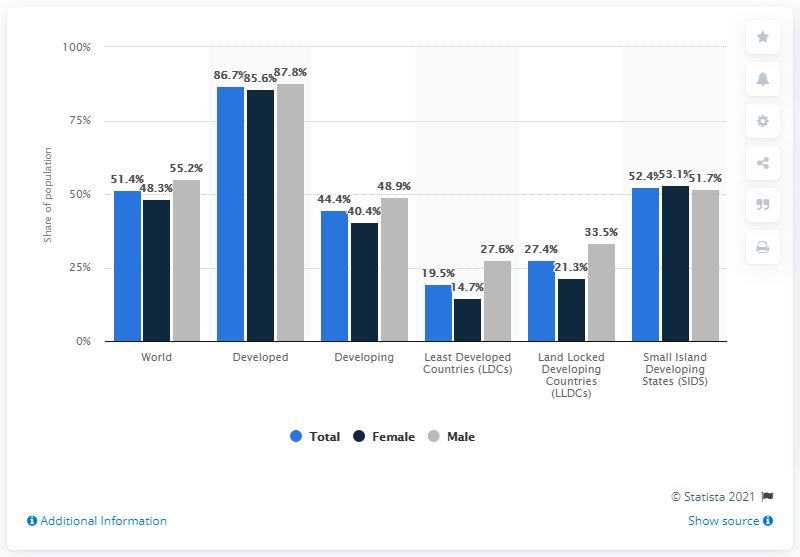Give some essential details in this illustration. In 2019, 48.3% of the global female population had access to the internet. In developed markets, approximately 85.6% of the female population had access to the internet. In 2019, 40.4% of the female population in developing markets had access to the internet. 